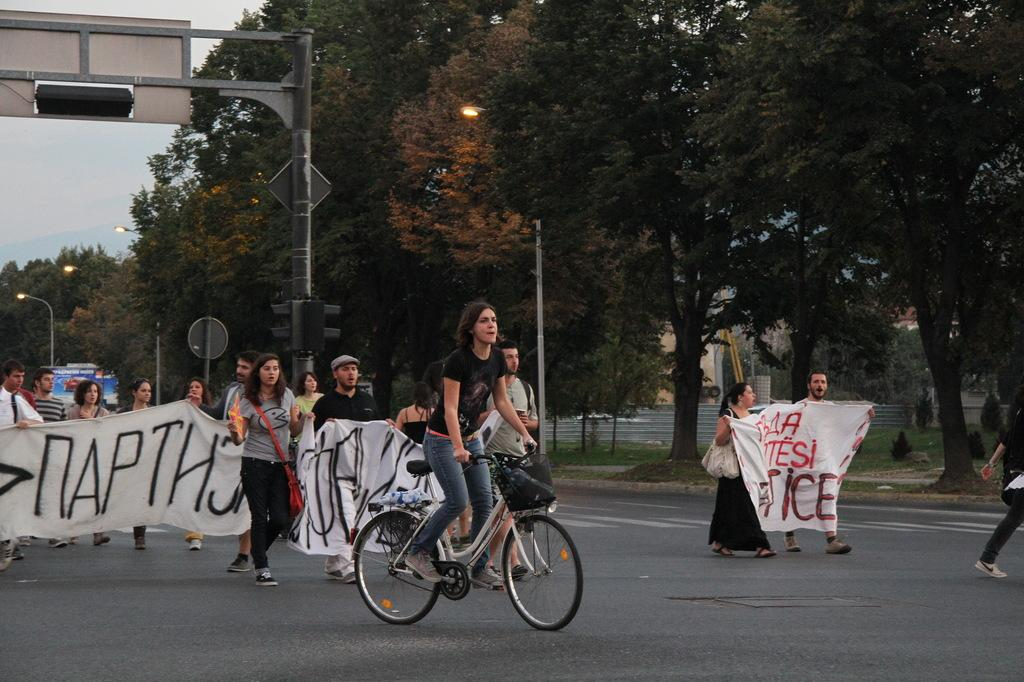What is the woman doing in the image? The woman is riding a bicycle in the image. What are the people in the image doing? The people are walking on the road and holding a banner in the image. What can be seen in the background of the image? Trees are visible around the scene in the image. What type of lighting is present in the image? Pole lights are present in the image. Where is the scarecrow placed in the image? There is no scarecrow present in the image. What season is depicted in the image? The provided facts do not mention the season, so it cannot be determined from the image. 